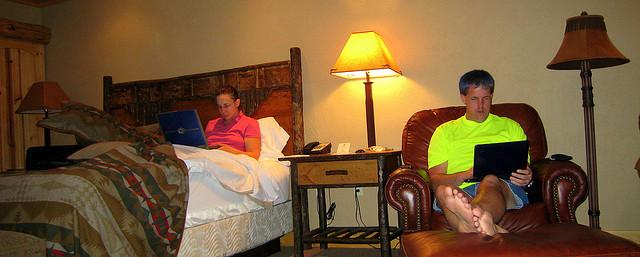Why are they so far apart?

Choices:
A) too crowded
B) quiet time
C) afraid
D) strangers quiet time 